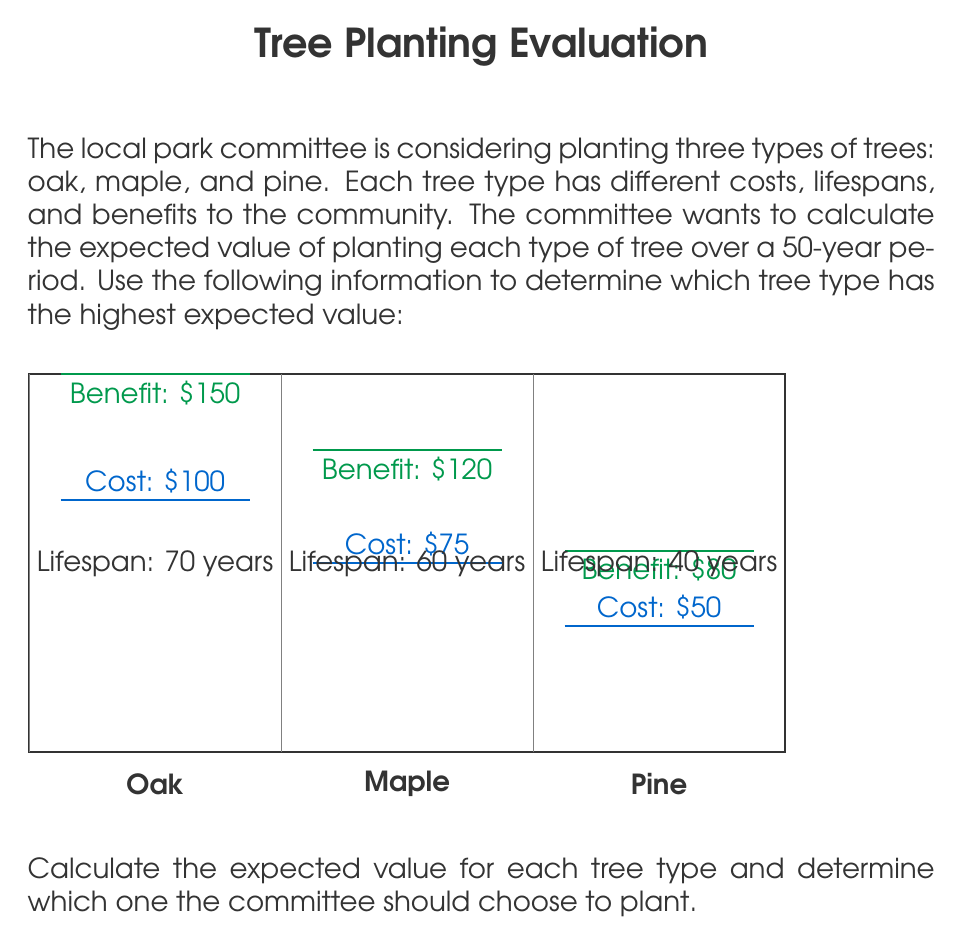Solve this math problem. To calculate the expected value for each tree type, we need to consider the costs, benefits, and lifespans over the 50-year period. We'll use the following formula:

$$\text{Expected Value} = \frac{\text{Total Benefits} - \text{Total Costs}}{\text{Number of Trees Planted}}$$

Step 1: Calculate the number of trees needed for each type over 50 years.
Oak: $\frac{50 \text{ years}}{70 \text{ years}} \approx 0.71 \text{ trees}$
Maple: $\frac{50 \text{ years}}{60 \text{ years}} \approx 0.83 \text{ trees}$
Pine: $\frac{50 \text{ years}}{40 \text{ years}} = 1.25 \text{ trees}$

Step 2: Calculate the total costs for each tree type.
Oak: $100 \times 0.71 = \$71$
Maple: $75 \times 0.83 = \$62.25$
Pine: $50 \times 1.25 = \$62.50$

Step 3: Calculate the total benefits for each tree type over 50 years.
Oak: $150 \times 50 = \$7,500$
Maple: $120 \times 50 = \$6,000$
Pine: $80 \times 50 = \$4,000$

Step 4: Calculate the expected value for each tree type.
Oak: $\frac{7,500 - 71}{0.71} \approx \$10,464.79$
Maple: $\frac{6,000 - 62.25}{0.83} \approx \$7,153.92$
Pine: $\frac{4,000 - 62.50}{1.25} = \$3,150$

Therefore, the oak trees have the highest expected value over the 50-year period.
Answer: Oak trees, with an expected value of $10,464.79 